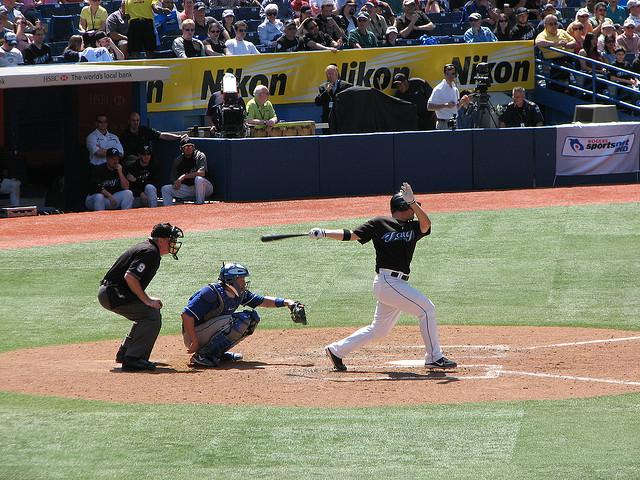What sport is being played in this picture?
Answer briefly. Baseball. What event is this?
Give a very brief answer. Baseball game. What color is the catcher's mitt?
Quick response, please. Black. 